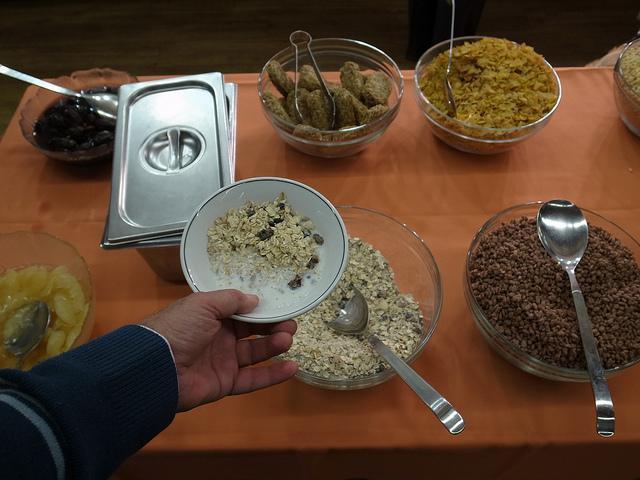What's most likely in the box?
Select the accurate response from the four choices given to answer the question.
Options: Napkins, more food, gas, water. More food. 